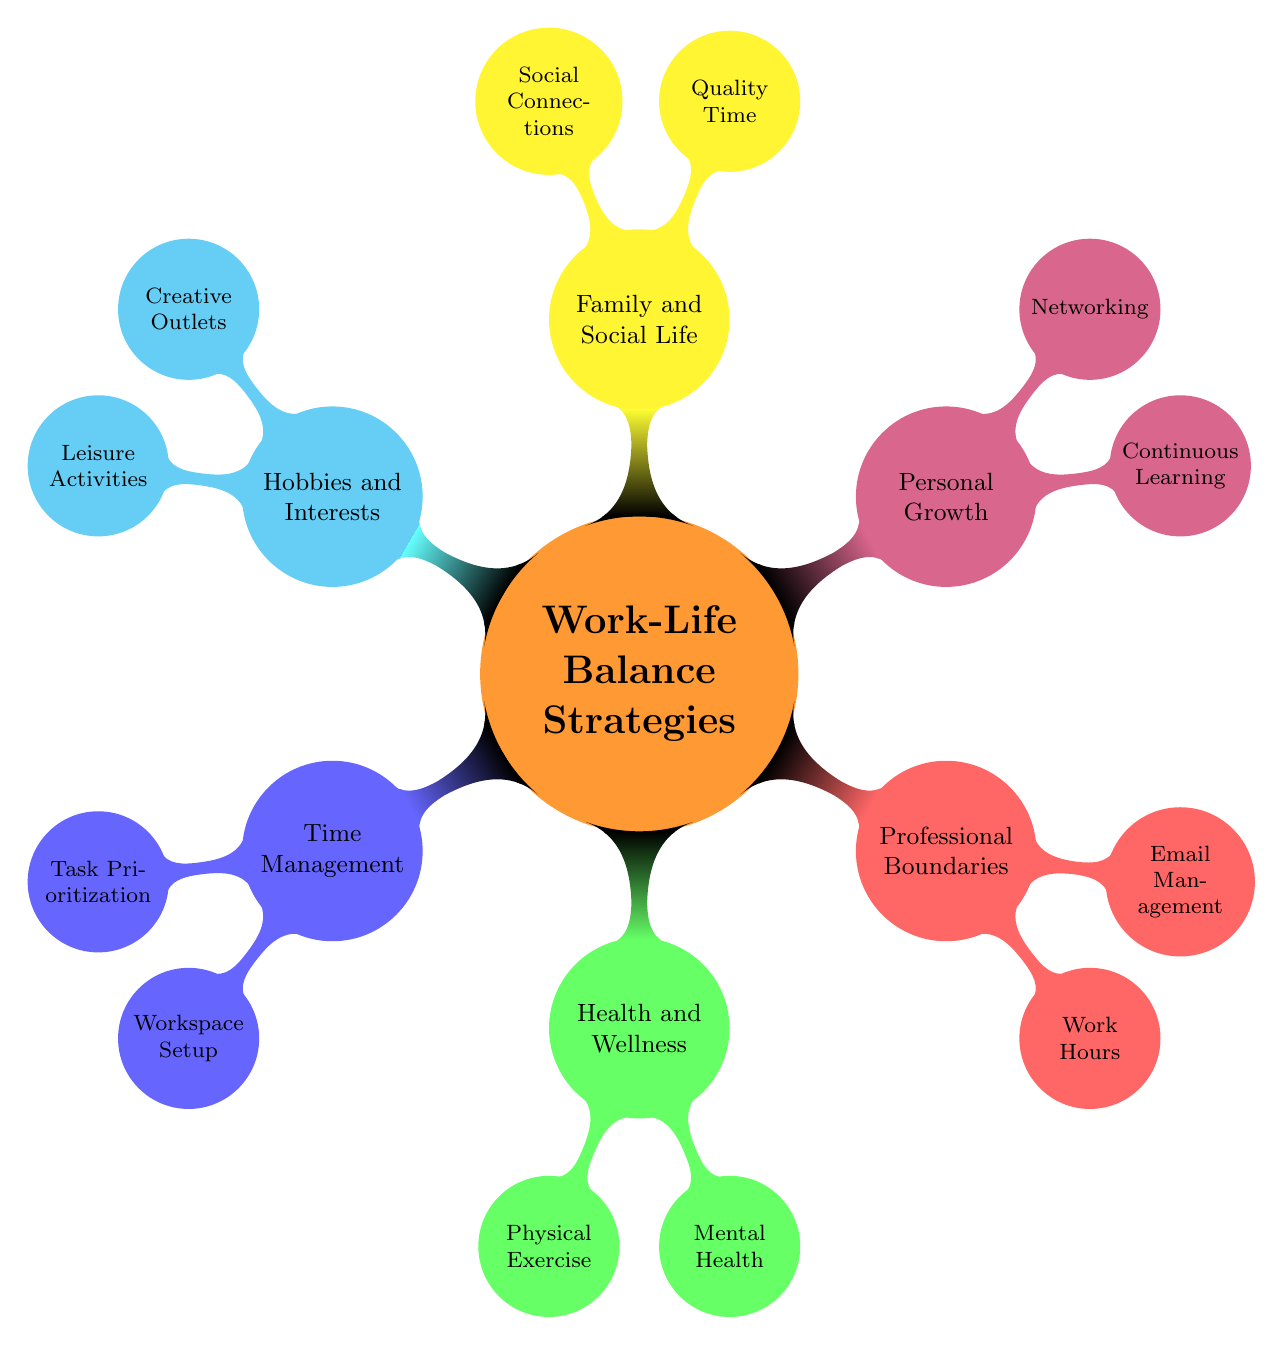What is the main topic of the mind map? The central node of the mind map clearly states "Work-Life Balance Strategies for Game Developers," which is the main theme being discussed.
Answer: Work-Life Balance Strategies for Game Developers How many main branches are in the diagram? There are six primary branches emanating from the central node, indicating the major areas of focus for work-life balance strategies.
Answer: 6 What is one strategy listed under Health and Wellness? Under the "Health and Wellness" branch, it specifically mentions "Physical Exercise," which is one of the strategies.
Answer: Physical Exercise Which strategy falls under Professional Boundaries? The "Professional Boundaries" branch includes "Email Management," which is specifically a strategy listed under it.
Answer: Email Management How many strategies are listed under Time Management? The "Time Management" branch contains two strategies listed: "Task Prioritization" and "Workspace Setup," making a total of two.
Answer: 2 Which two methods are mentioned under Task Prioritization? The "Task Prioritization" node lists two specific methods: "Eisenhower Matrix" and "Pareto Principle," indicating effective methods of prioritization.
Answer: Eisenhower Matrix, Pareto Principle Which two activities are included under Leisure Activities? The "Leisure Activities" node includes "Gaming for Fun" and "Reading," which are two activities for leisure enjoyment.
Answer: Gaming for Fun, Reading What is the relationship between Professional Boundaries and Email Management? Email Management is a specific strategy that falls under the broader category of Professional Boundaries, illustrating a focus area for managing work and personal life through email practices.
Answer: Email Management is under Professional Boundaries What is a common theme between Family and Social Life and Hobbies and Interests? Both branches emphasize the importance of personal fulfillment outside of work; "Quality Time" and "Creative Outlets" showcase different ways to achieve balance in personal life.
Answer: Personal Fulfillment What type of growth is emphasized in Personal Growth? The "Personal Growth" branch emphasizes "Continuous Learning," which indicates a focus on developing skills and knowledge as a key strategy for overall growth.
Answer: Continuous Learning 